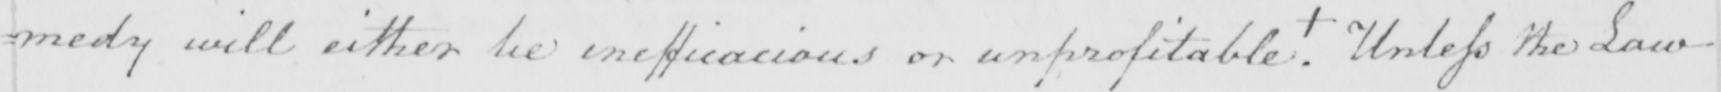What text is written in this handwritten line? : medy will either be inefficacious or unprofitable . +  Unless the Law 